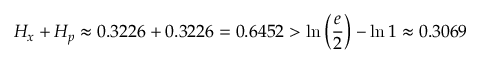Convert formula to latex. <formula><loc_0><loc_0><loc_500><loc_500>H _ { x } + H _ { p } \approx 0 . 3 2 2 6 + 0 . 3 2 2 6 = 0 . 6 4 5 2 > \ln \left ( { \frac { e } { 2 } } \right ) - \ln 1 \approx 0 . 3 0 6 9</formula> 